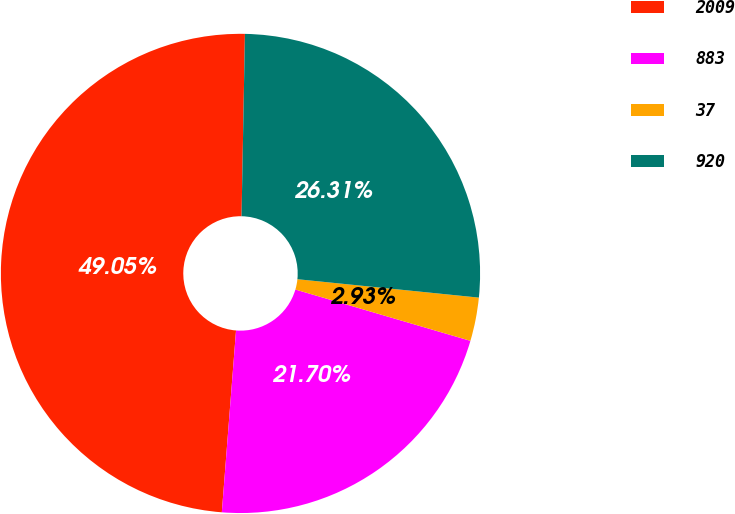Convert chart. <chart><loc_0><loc_0><loc_500><loc_500><pie_chart><fcel>2009<fcel>883<fcel>37<fcel>920<nl><fcel>49.05%<fcel>21.7%<fcel>2.93%<fcel>26.31%<nl></chart> 